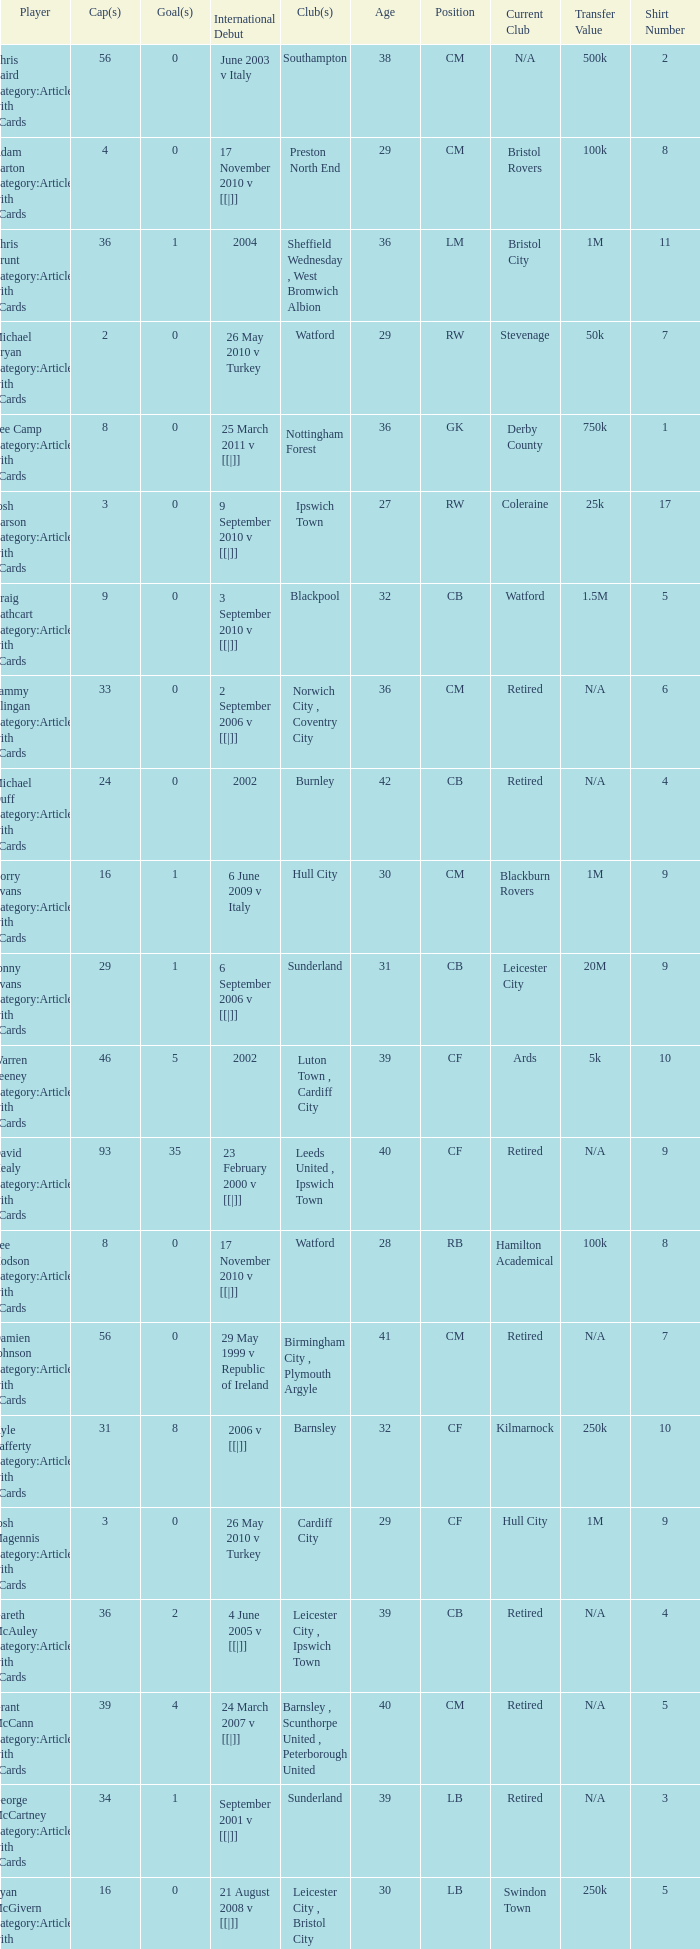How many caps figures are there for Norwich City, Coventry City? 1.0. 